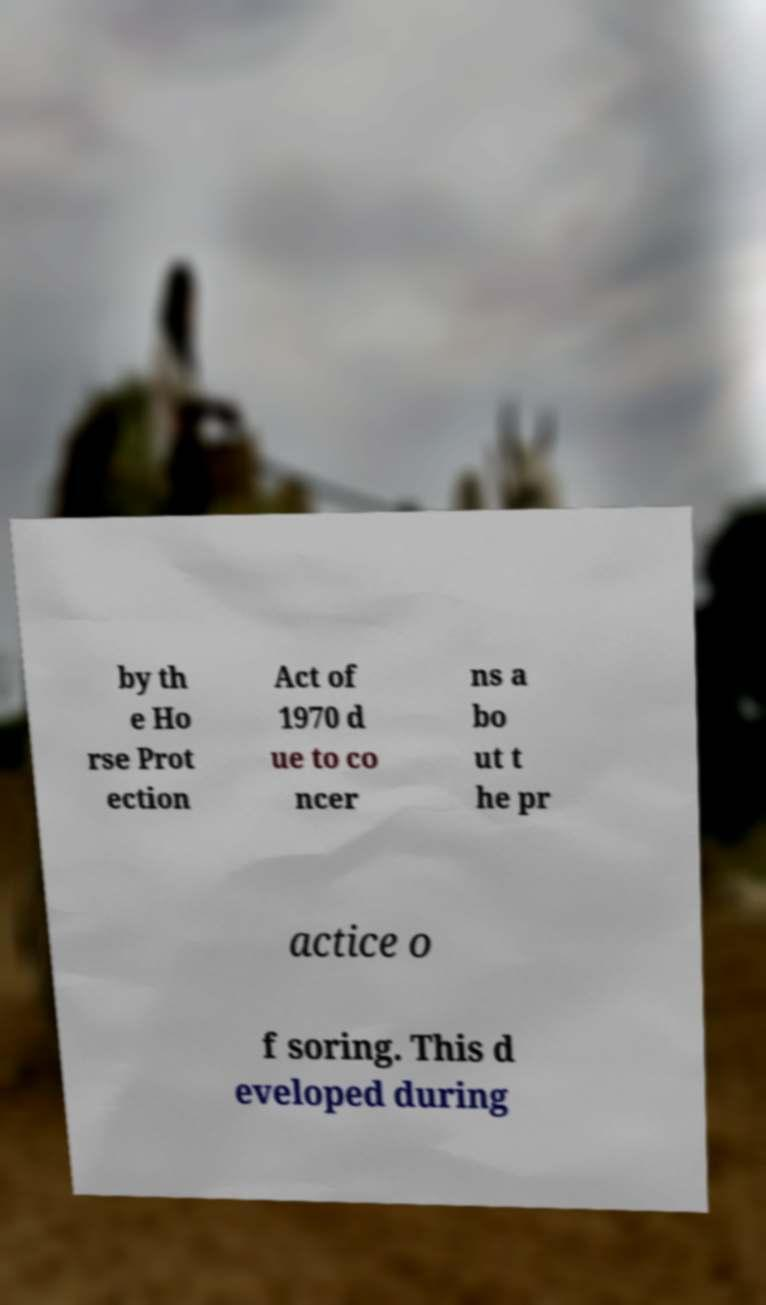Can you accurately transcribe the text from the provided image for me? by th e Ho rse Prot ection Act of 1970 d ue to co ncer ns a bo ut t he pr actice o f soring. This d eveloped during 